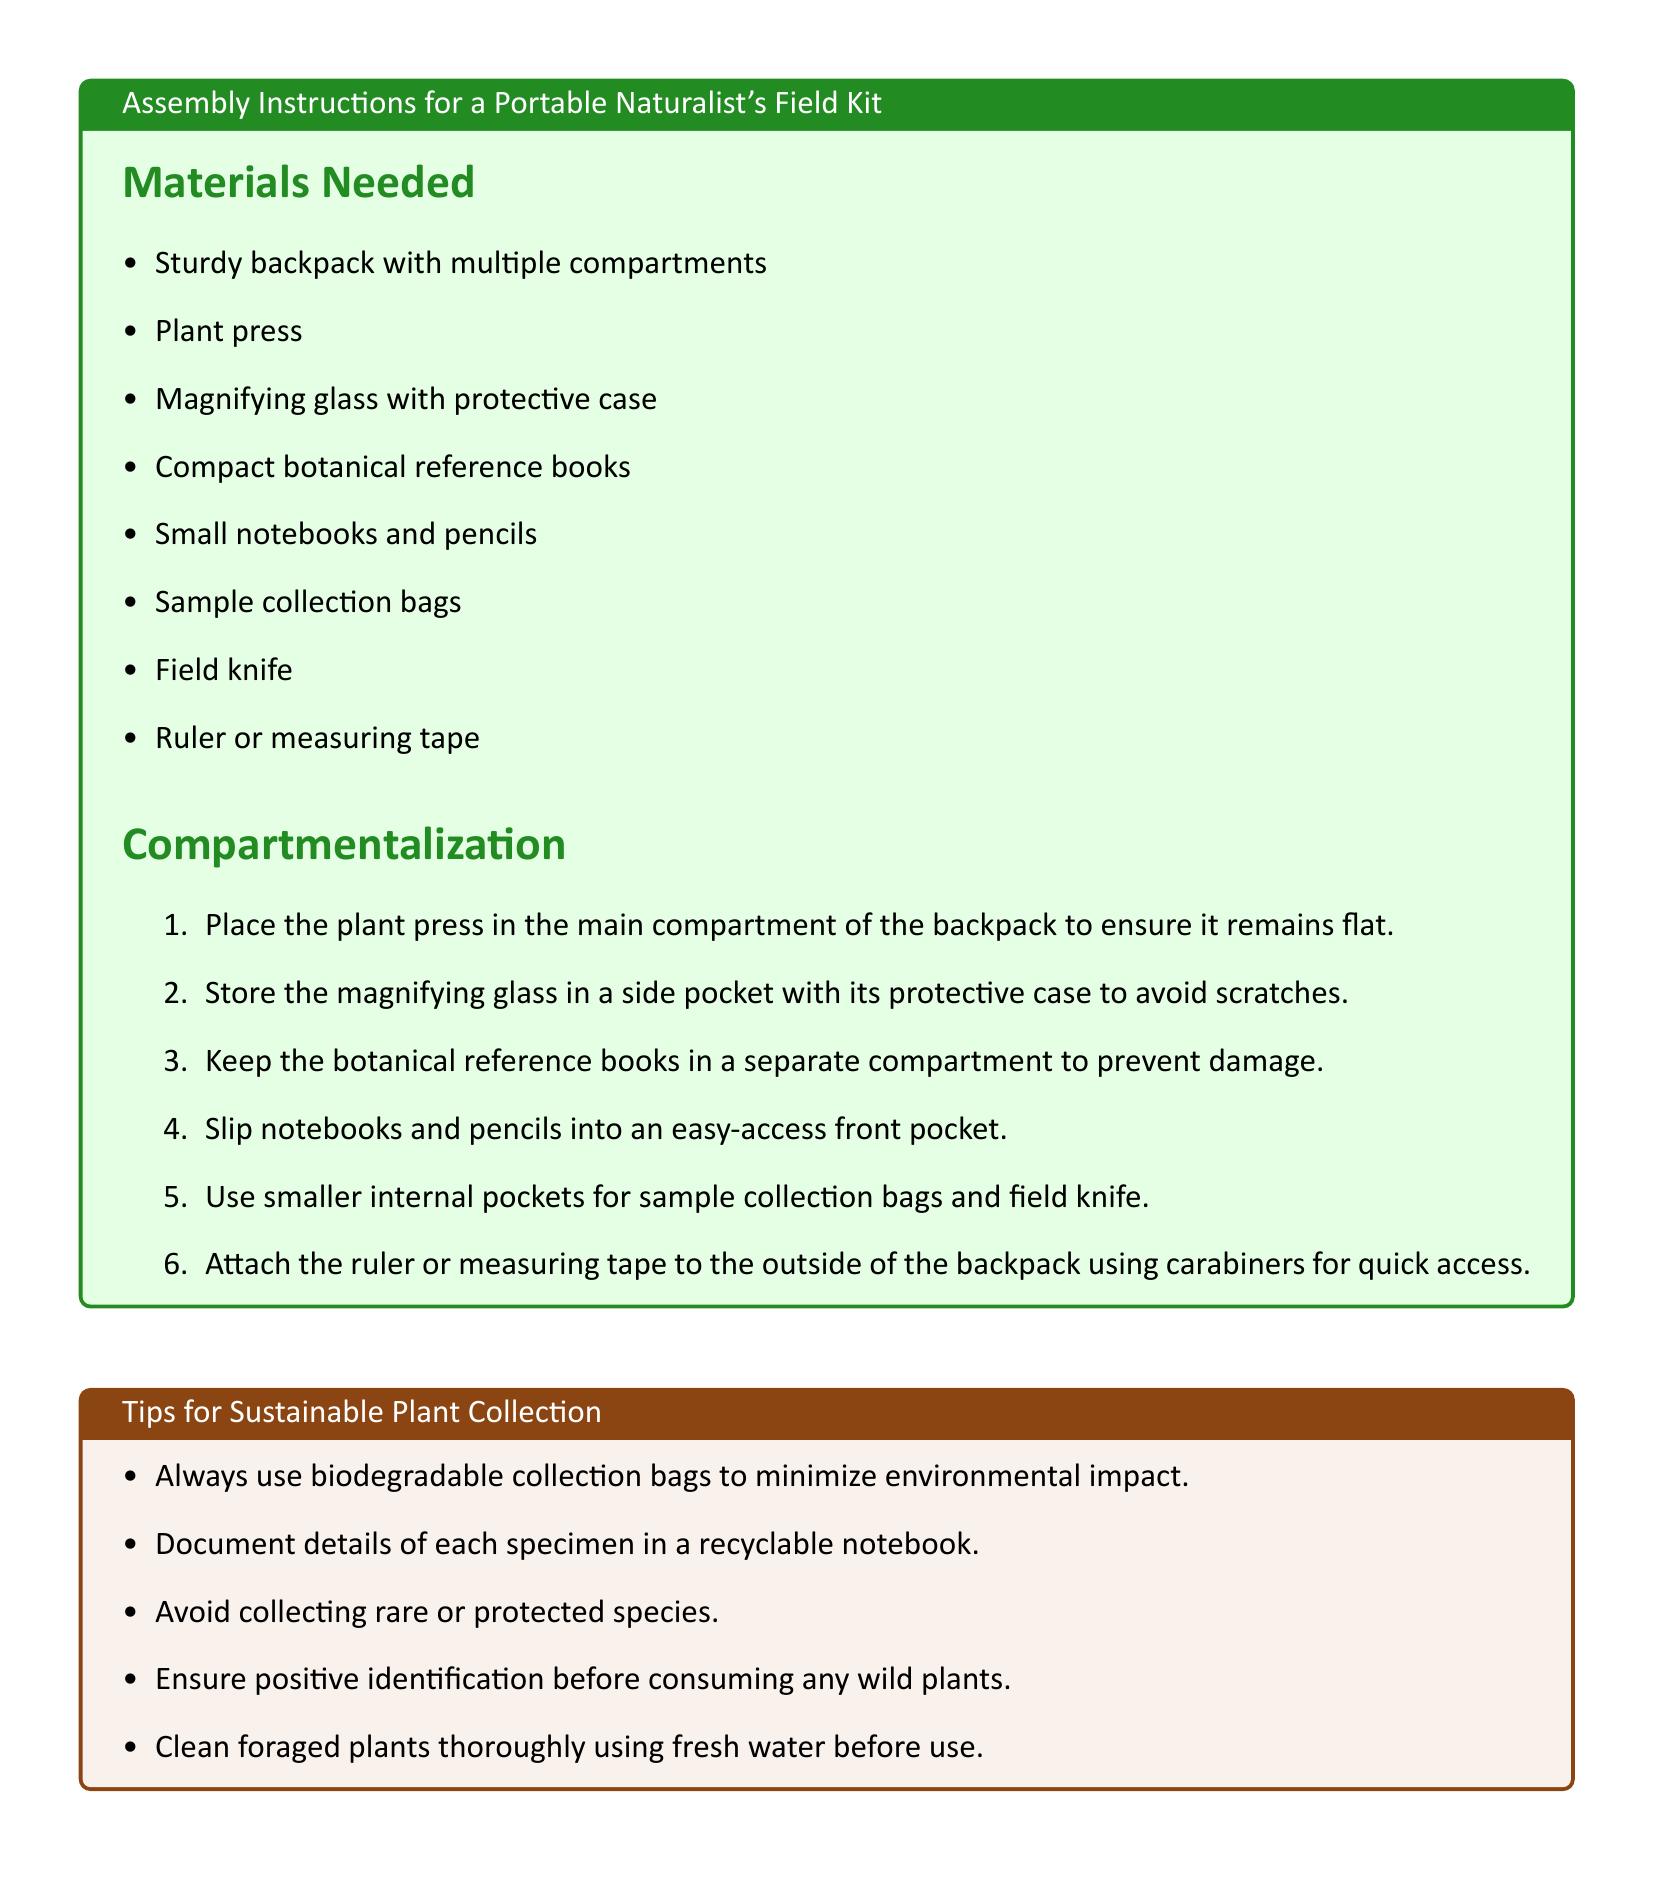What is the main compartment item for the field kit? The main compartment item is the plant press, which is listed as needing to be placed flat inside the backpack.
Answer: plant press How many items are listed under materials needed? The total number of items listed is derived from counting each bullet point in the material section, which includes 8 items.
Answer: 8 Where should the magnifying glass be stored? The magnifying glass should be stored in a side pocket with its protective case to prevent scratches.
Answer: side pocket What type of collection bags should be used to minimize environmental impact? Biodegradable collection bags are recommended for sustainable plant collection in the tips section of the document.
Answer: biodegradable Which cooking method is suggested for foraged plants? The document suggests preparing meals like foraged greens stir-fry as a cooking method using collected plants.
Answer: stir-fry What color is the title box for tips on sustainable plant collection? The title box for tips on sustainable plant collection is in a brown color scheme.
Answer: brown What item could be attached to the backpack using carabiners? The ruler or measuring tape is suggested to be attached to the outside of the backpack using carabiners for quick access.
Answer: ruler or measuring tape What should precede the collection of wild plants? The document emphasizes the importance of positive identification before consuming any wild plants as a safety guideline.
Answer: positive identification 